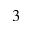<formula> <loc_0><loc_0><loc_500><loc_500>3</formula> 